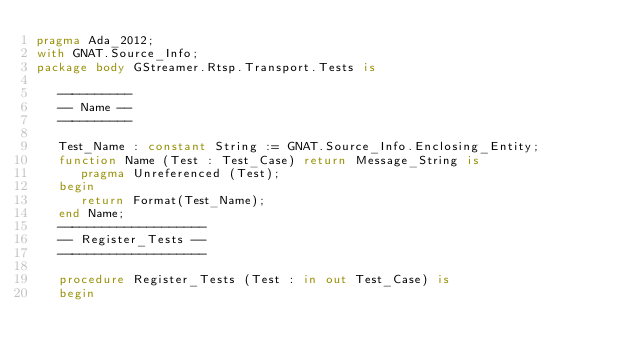Convert code to text. <code><loc_0><loc_0><loc_500><loc_500><_Ada_>pragma Ada_2012;
with GNAT.Source_Info;
package body GStreamer.Rtsp.Transport.Tests is

   ----------
   -- Name --
   ----------

   Test_Name : constant String := GNAT.Source_Info.Enclosing_Entity;
   function Name (Test : Test_Case) return Message_String is
      pragma Unreferenced (Test);
   begin
      return Format(Test_Name);
   end Name;
   --------------------
   -- Register_Tests --
   --------------------

   procedure Register_Tests (Test : in out Test_Case) is
   begin</code> 